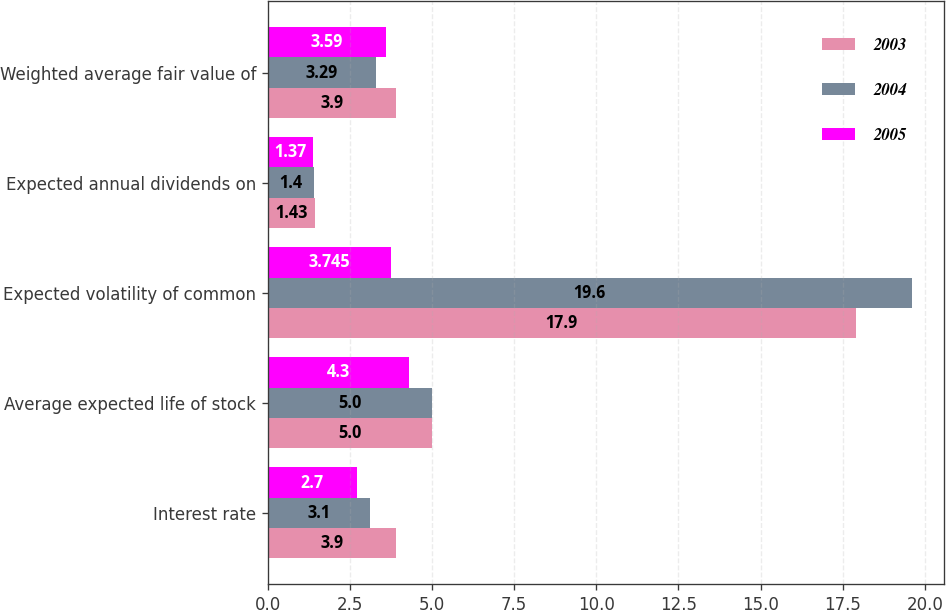Convert chart to OTSL. <chart><loc_0><loc_0><loc_500><loc_500><stacked_bar_chart><ecel><fcel>Interest rate<fcel>Average expected life of stock<fcel>Expected volatility of common<fcel>Expected annual dividends on<fcel>Weighted average fair value of<nl><fcel>2003<fcel>3.9<fcel>5<fcel>17.9<fcel>1.43<fcel>3.9<nl><fcel>2004<fcel>3.1<fcel>5<fcel>19.6<fcel>1.4<fcel>3.29<nl><fcel>2005<fcel>2.7<fcel>4.3<fcel>3.745<fcel>1.37<fcel>3.59<nl></chart> 